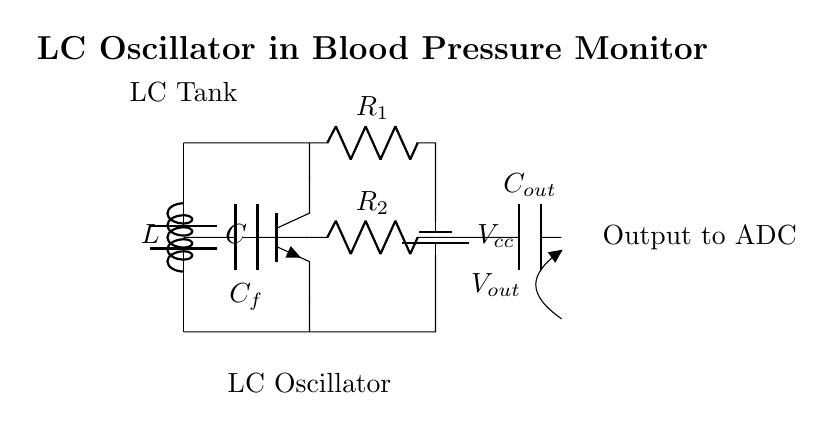What is the type of oscillator depicted in this circuit? The circuit shown represents an LC oscillator, characterized by the presence of inductor (L) and capacitor (C) components that resonate and produce oscillations.
Answer: LC oscillator What component is labeled as C_f? C_f stands for the feedback capacitor, which plays a critical role in providing positive feedback necessary for sustaining the oscillation of the circuit.
Answer: Feedback capacitor How many resistors are present in the circuit? There are two resistors labeled as R_1 and R_2, which are used for biasing the transistor and establishing the operating point of the oscillator.
Answer: Two What is the purpose of the LC tank in this circuit? The LC tank, formed by the inductor and capacitor, is responsible for generating oscillatory signals at a specific frequency determined by their values, which is essential for creating the oscillation in the circuit.
Answer: Generate oscillatory signals Describe the output component connected to V_out. The output component connected to V_out is a capacitor labeled as C_out, which is used to filter or couple the oscillation signal to the output measurement system of the blood pressure monitor.
Answer: Capacitor C_out Which type of transistor is used in this design? The design uses an NPN transistor, indicated by the notation Tnpn, which helps to amplify the oscillatory signal generated in the LC oscillator circuit for output.
Answer: NPN 